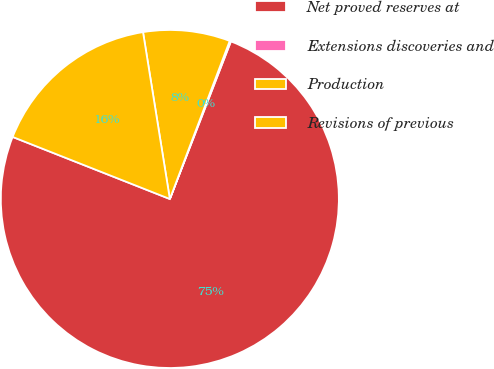Convert chart. <chart><loc_0><loc_0><loc_500><loc_500><pie_chart><fcel>Net proved reserves at<fcel>Extensions discoveries and<fcel>Production<fcel>Revisions of previous<nl><fcel>75.1%<fcel>0.12%<fcel>8.3%<fcel>16.48%<nl></chart> 